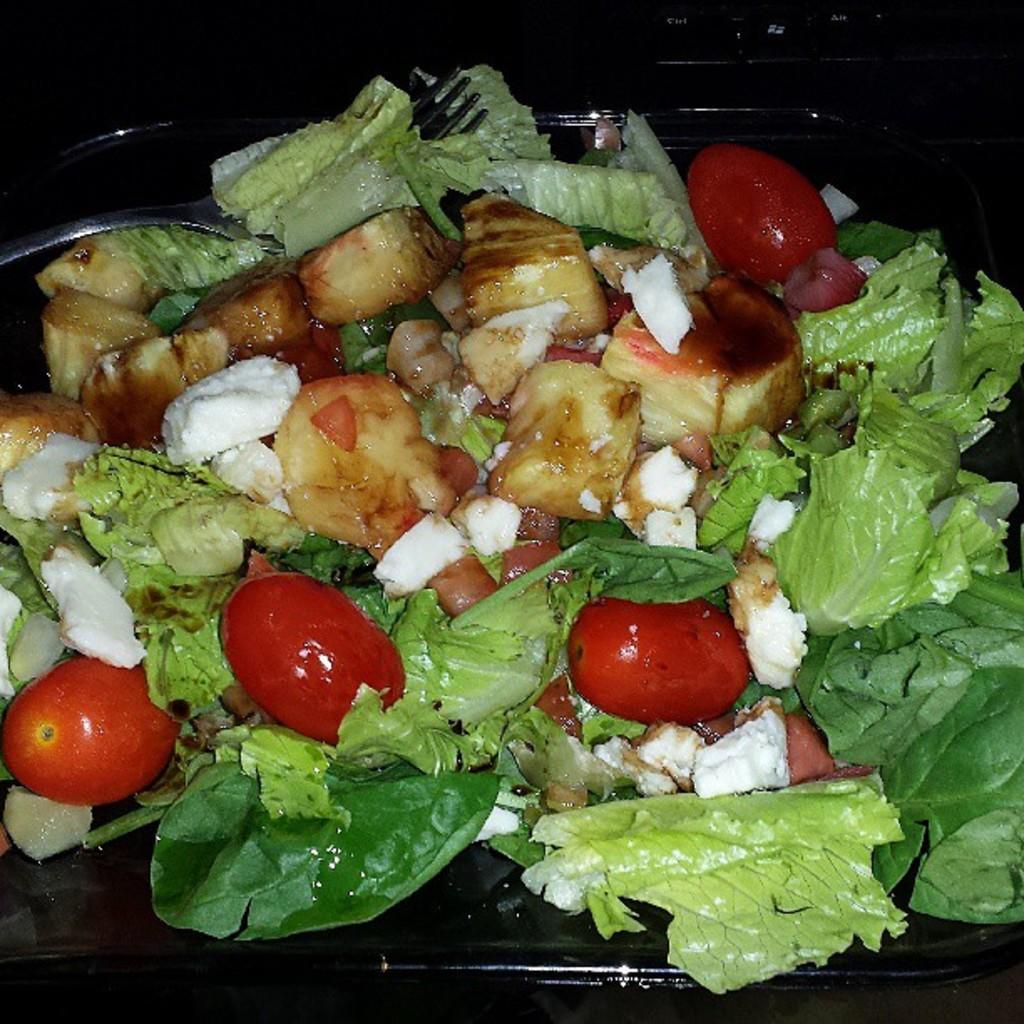Can you describe this image briefly? In the image there is a black tray with leaves, tomatoes and some other food items. And also there is a fork. 